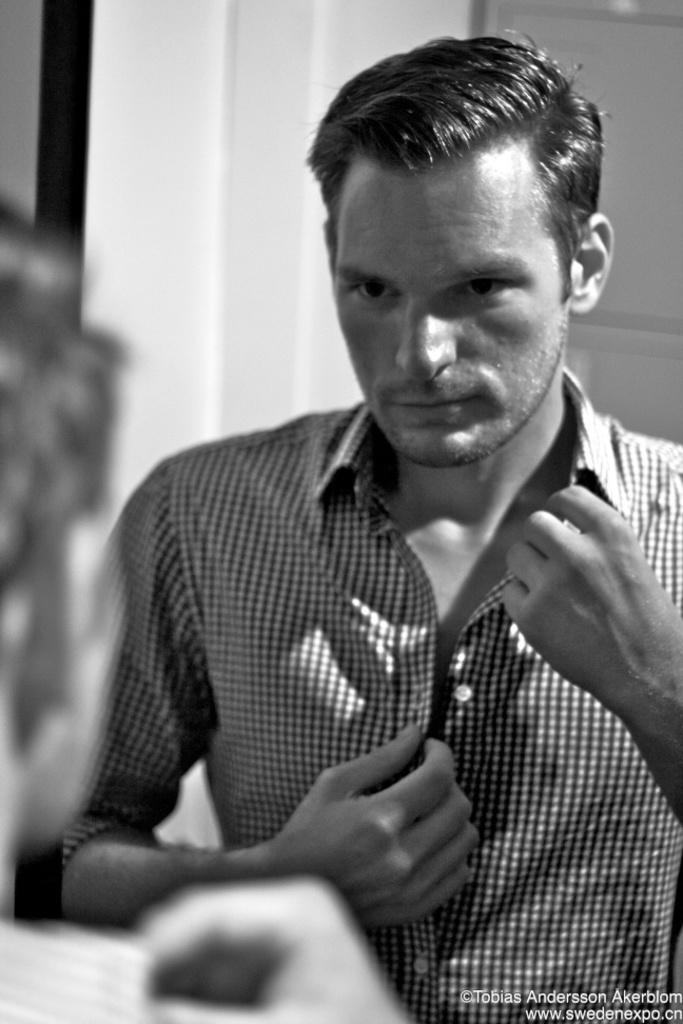What is the color scheme of the image? The image is black and white. How many people are in the image? There are two persons in the image. What is located behind the persons? There is a pillar and a wall visible behind the persons. Is there any text in the image? Yes, there is some text at the bottom of the image. What type of scarecrow can be seen standing near the sea in the image? There is no scarecrow or sea present in the image; it features two persons, a pillar, and a wall in a black and white setting. What is located at the top of the image? There is no specific element located at the top of the image. 